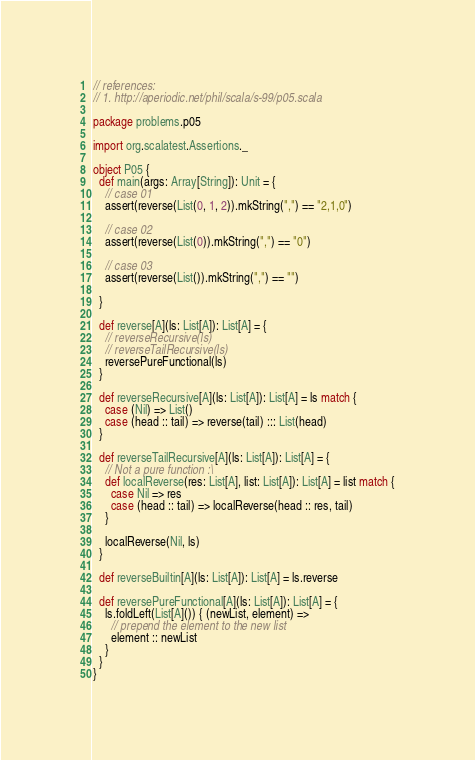<code> <loc_0><loc_0><loc_500><loc_500><_Scala_>// references:
// 1. http://aperiodic.net/phil/scala/s-99/p05.scala

package problems.p05

import org.scalatest.Assertions._

object P05 {
  def main(args: Array[String]): Unit = {
    // case 01
    assert(reverse(List(0, 1, 2)).mkString(",") == "2,1,0")

    // case 02
    assert(reverse(List(0)).mkString(",") == "0")

    // case 03
    assert(reverse(List()).mkString(",") == "")

  }

  def reverse[A](ls: List[A]): List[A] = {
    // reverseRecursive(ls)
    // reverseTailRecursive(ls)
    reversePureFunctional(ls)
  }

  def reverseRecursive[A](ls: List[A]): List[A] = ls match {
    case (Nil) => List()
    case (head :: tail) => reverse(tail) ::: List(head)
  }

  def reverseTailRecursive[A](ls: List[A]): List[A] = {
    // Not a pure function :\
    def localReverse(res: List[A], list: List[A]): List[A] = list match {
      case Nil => res
      case (head :: tail) => localReverse(head :: res, tail)
    }

    localReverse(Nil, ls)
  }

  def reverseBuiltin[A](ls: List[A]): List[A] = ls.reverse

  def reversePureFunctional[A](ls: List[A]): List[A] = {
    ls.foldLeft(List[A]()) { (newList, element) =>
      // prepend the element to the new list
      element :: newList
    }
  }
}
</code> 